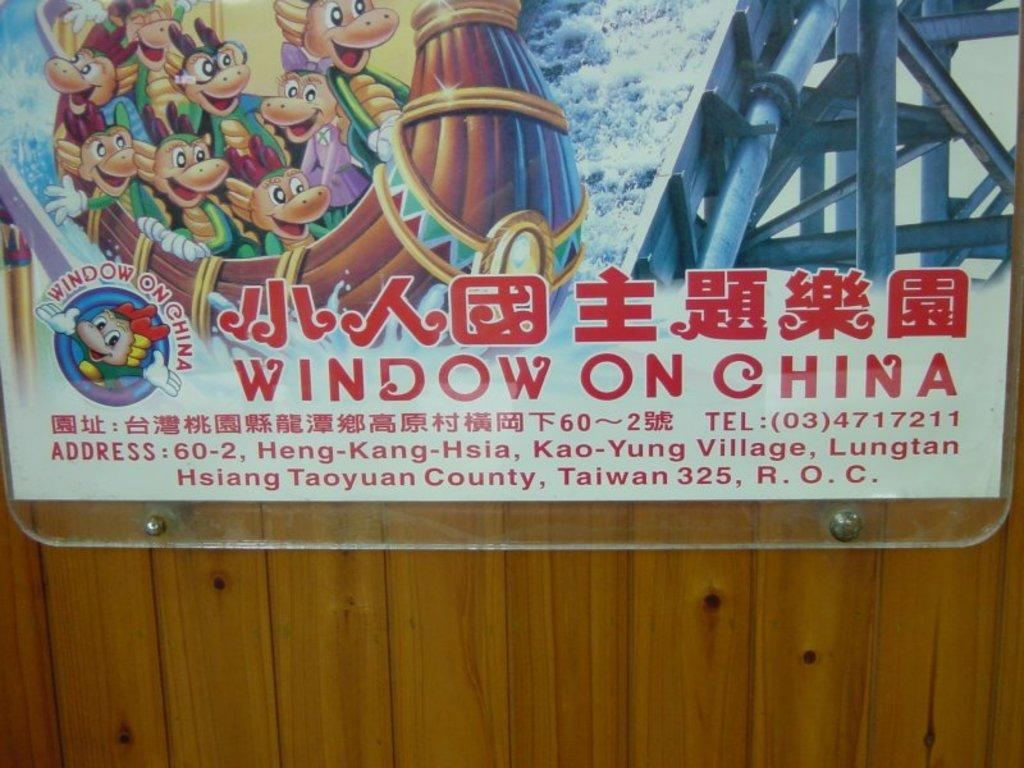<image>
Offer a succinct explanation of the picture presented. A cartoon poster which has the words window on China on it. 